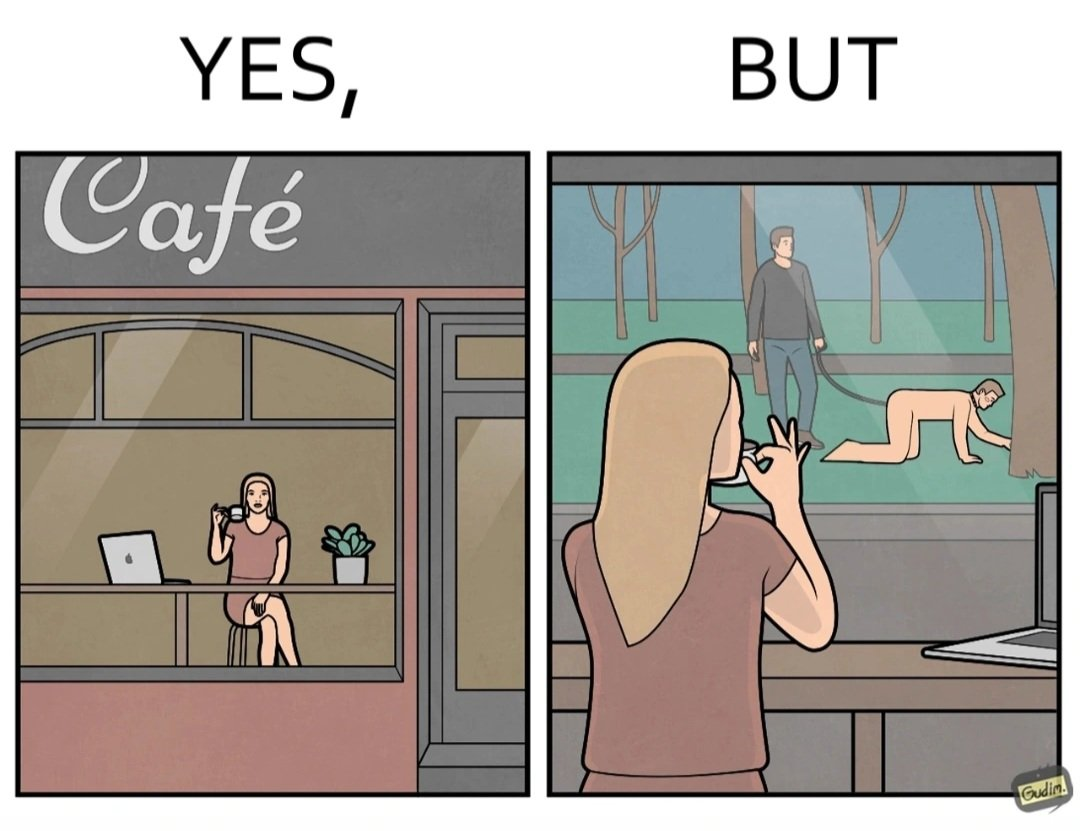Describe what you see in this image. The image is ironic, because in the first image a woman is seen enjoying her coffee, while watching the injustice happening outside without even having a single thought on the injustice outside and taking some actions or raising some concerns over it 